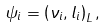<formula> <loc_0><loc_0><loc_500><loc_500>\psi _ { i } = \left ( \nu _ { i } , l _ { i } \right ) _ { L } ,</formula> 